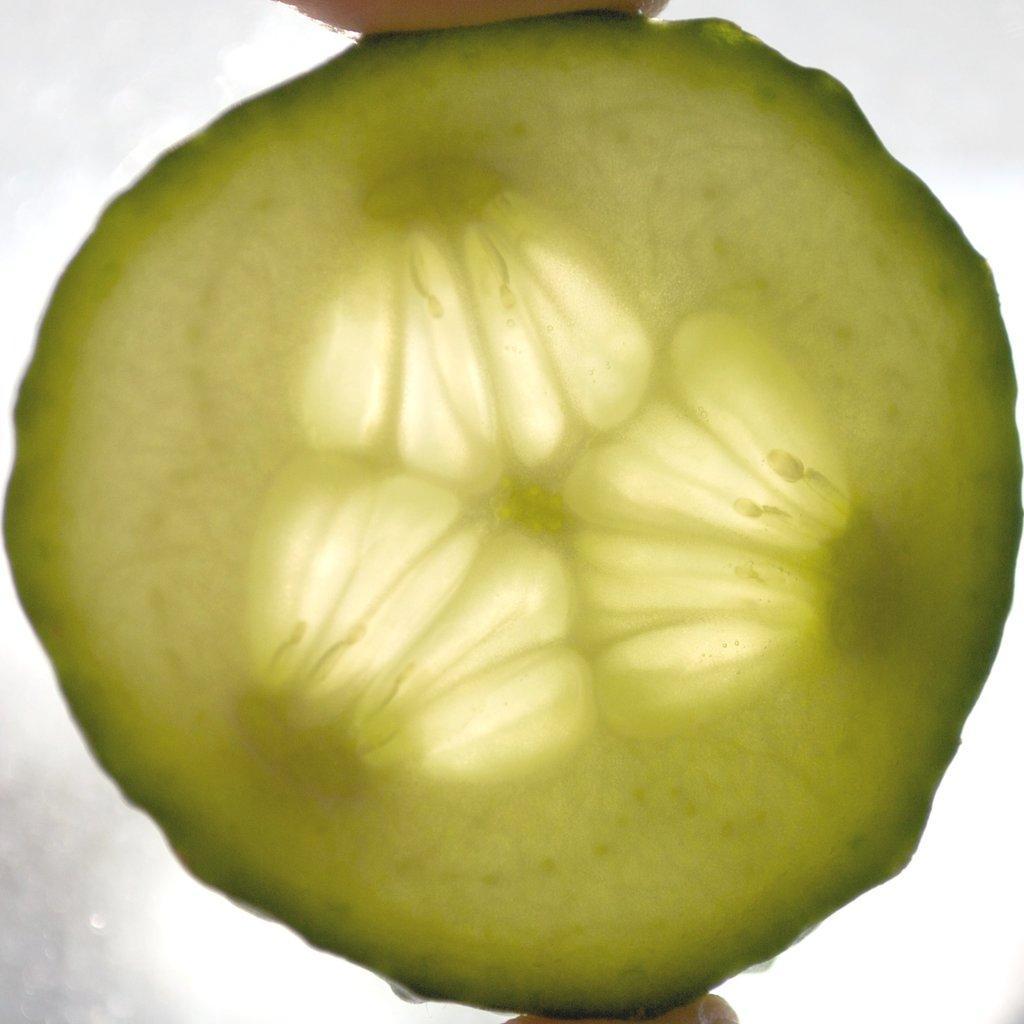How would you summarize this image in a sentence or two? There is a person holding a cucumber piece is circle in shape, with two fingers. The background is white in color. 